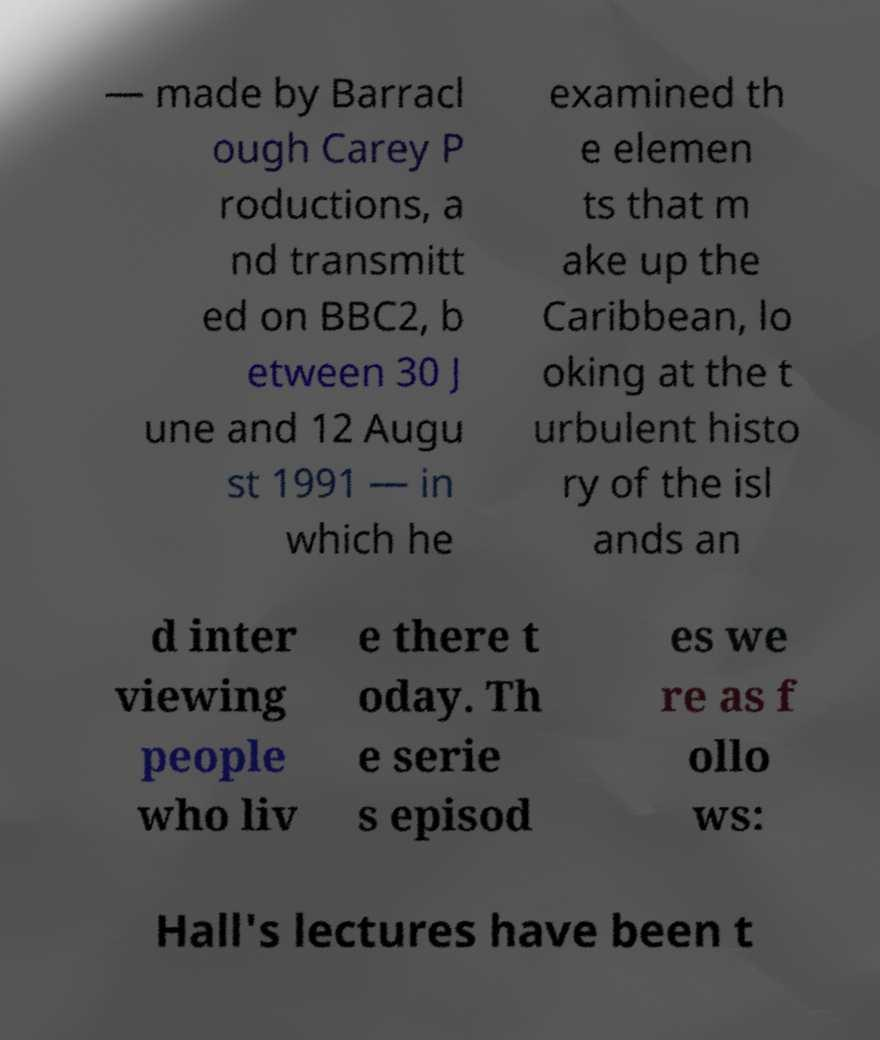There's text embedded in this image that I need extracted. Can you transcribe it verbatim? — made by Barracl ough Carey P roductions, a nd transmitt ed on BBC2, b etween 30 J une and 12 Augu st 1991 — in which he examined th e elemen ts that m ake up the Caribbean, lo oking at the t urbulent histo ry of the isl ands an d inter viewing people who liv e there t oday. Th e serie s episod es we re as f ollo ws: Hall's lectures have been t 